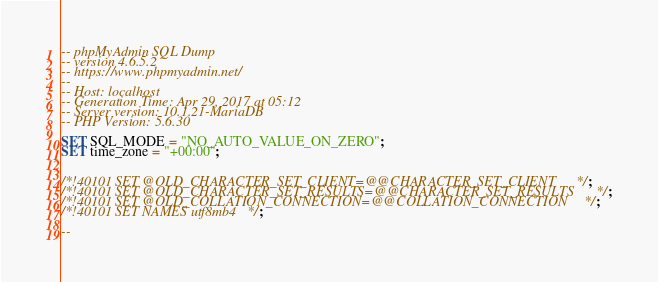Convert code to text. <code><loc_0><loc_0><loc_500><loc_500><_SQL_>-- phpMyAdmin SQL Dump
-- version 4.6.5.2
-- https://www.phpmyadmin.net/
--
-- Host: localhost
-- Generation Time: Apr 29, 2017 at 05:12 
-- Server version: 10.1.21-MariaDB
-- PHP Version: 5.6.30

SET SQL_MODE = "NO_AUTO_VALUE_ON_ZERO";
SET time_zone = "+00:00";


/*!40101 SET @OLD_CHARACTER_SET_CLIENT=@@CHARACTER_SET_CLIENT */;
/*!40101 SET @OLD_CHARACTER_SET_RESULTS=@@CHARACTER_SET_RESULTS */;
/*!40101 SET @OLD_COLLATION_CONNECTION=@@COLLATION_CONNECTION */;
/*!40101 SET NAMES utf8mb4 */;

--</code> 